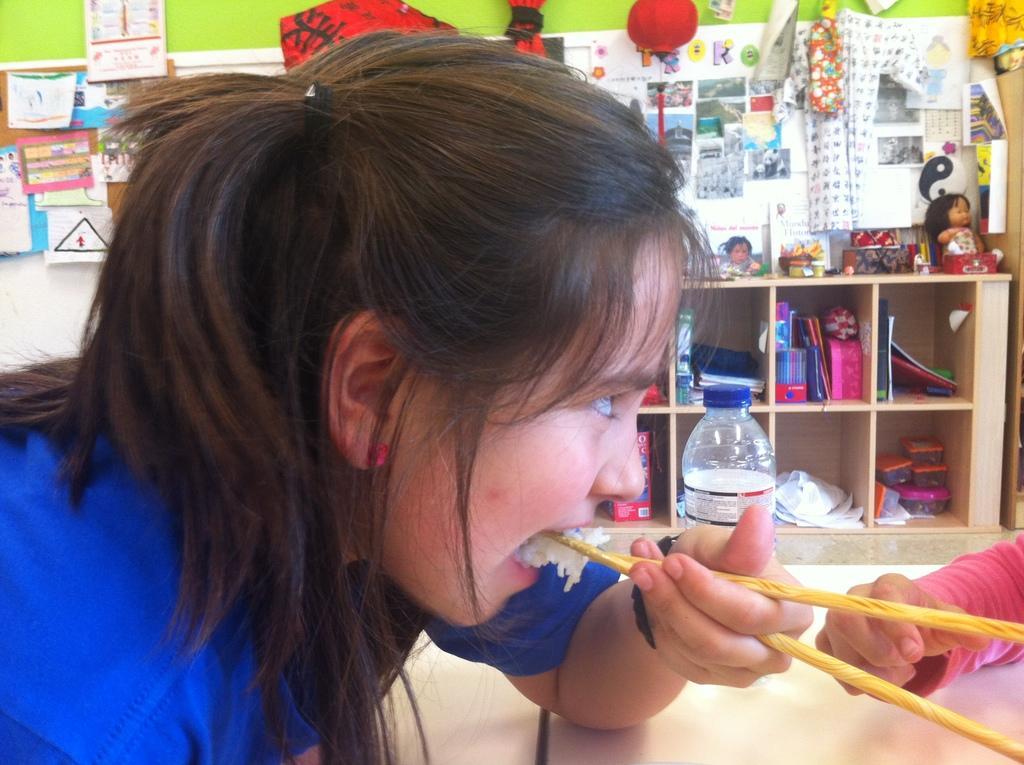Please provide a concise description of this image. In this picture we can see woman eating with chopsticks and on table we have bottle and in background we can see wall with posters, calendar here racks with books, boxes in it, toys. 